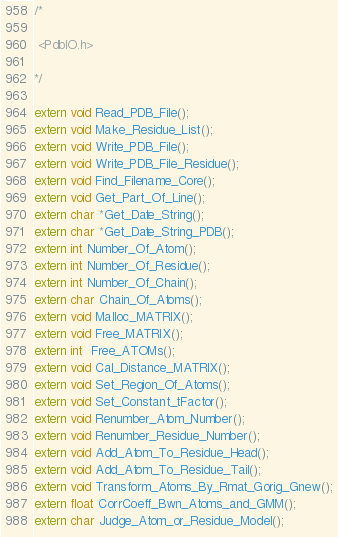<code> <loc_0><loc_0><loc_500><loc_500><_C_>/*

 <PdbIO.h>

*/

extern void Read_PDB_File();
extern void Make_Residue_List();
extern void Write_PDB_File();
extern void Write_PDB_File_Residue();
extern void Find_Filename_Core();
extern void Get_Part_Of_Line();
extern char *Get_Date_String();
extern char *Get_Date_String_PDB();
extern int Number_Of_Atom();
extern int Number_Of_Residue();
extern int Number_Of_Chain();
extern char Chain_Of_Atoms();
extern void Malloc_MATRIX();
extern void Free_MATRIX();
extern int  Free_ATOMs();
extern void Cal_Distance_MATRIX();
extern void Set_Region_Of_Atoms();
extern void Set_Constant_tFactor();
extern void Renumber_Atom_Number();
extern void Renumber_Residue_Number();
extern void Add_Atom_To_Residue_Head();
extern void Add_Atom_To_Residue_Tail();
extern void Transform_Atoms_By_Rmat_Gorig_Gnew();
extern float CorrCoeff_Bwn_Atoms_and_GMM();
extern char Judge_Atom_or_Residue_Model();


</code> 